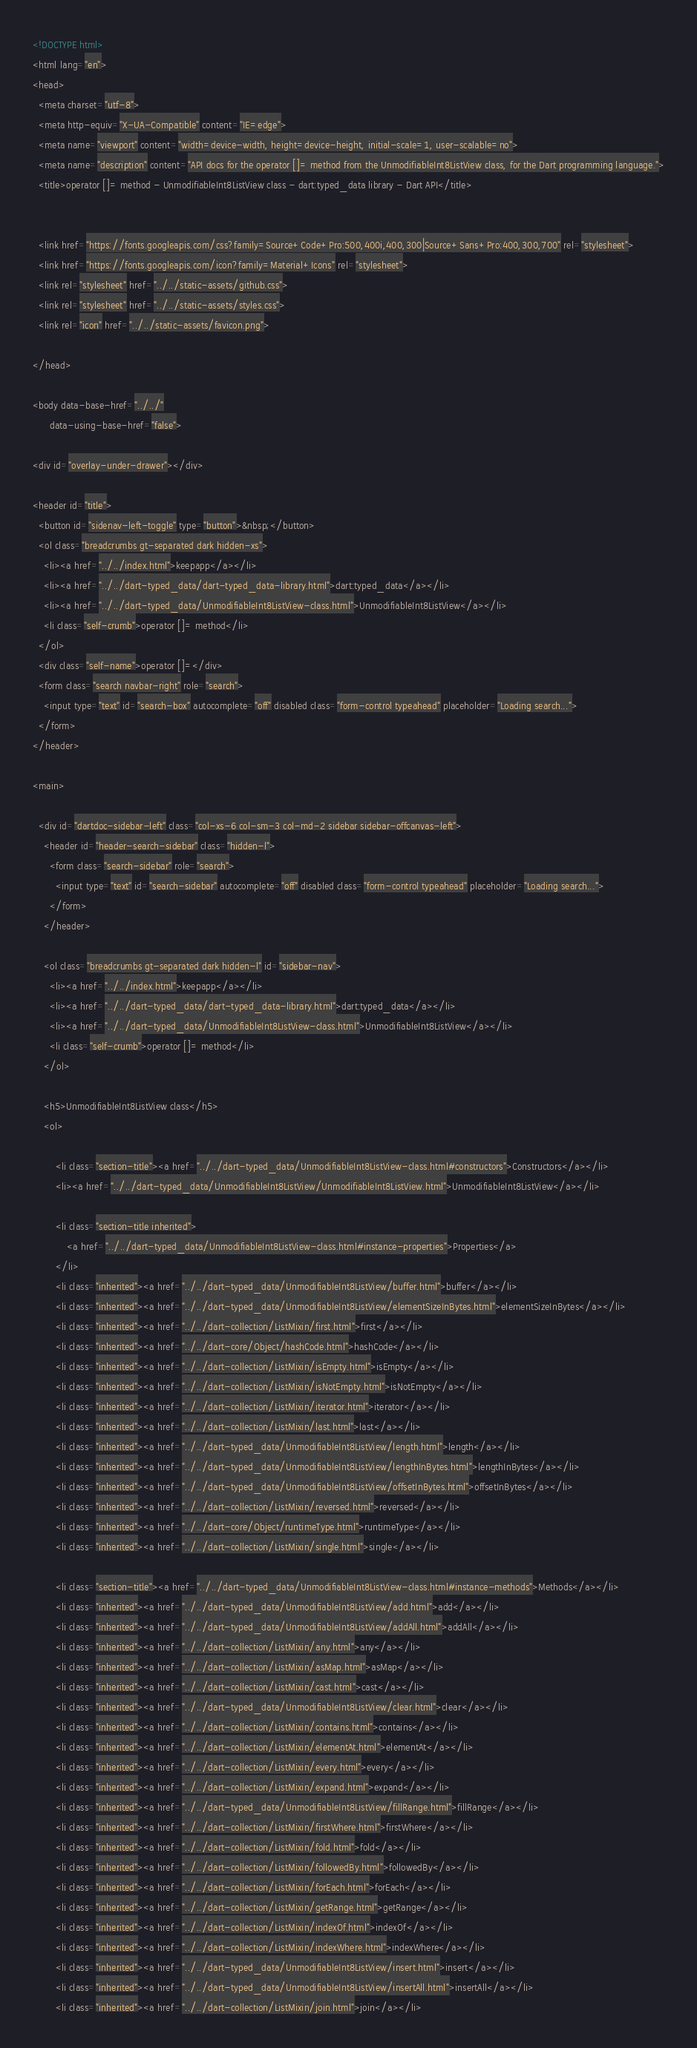Convert code to text. <code><loc_0><loc_0><loc_500><loc_500><_HTML_><!DOCTYPE html>
<html lang="en">
<head>
  <meta charset="utf-8">
  <meta http-equiv="X-UA-Compatible" content="IE=edge">
  <meta name="viewport" content="width=device-width, height=device-height, initial-scale=1, user-scalable=no">
  <meta name="description" content="API docs for the operator []= method from the UnmodifiableInt8ListView class, for the Dart programming language.">
  <title>operator []= method - UnmodifiableInt8ListView class - dart:typed_data library - Dart API</title>

  
  <link href="https://fonts.googleapis.com/css?family=Source+Code+Pro:500,400i,400,300|Source+Sans+Pro:400,300,700" rel="stylesheet">
  <link href="https://fonts.googleapis.com/icon?family=Material+Icons" rel="stylesheet">
  <link rel="stylesheet" href="../../static-assets/github.css">
  <link rel="stylesheet" href="../../static-assets/styles.css">
  <link rel="icon" href="../../static-assets/favicon.png">

</head>

<body data-base-href="../../"
      data-using-base-href="false">

<div id="overlay-under-drawer"></div>

<header id="title">
  <button id="sidenav-left-toggle" type="button">&nbsp;</button>
  <ol class="breadcrumbs gt-separated dark hidden-xs">
    <li><a href="../../index.html">keepapp</a></li>
    <li><a href="../../dart-typed_data/dart-typed_data-library.html">dart:typed_data</a></li>
    <li><a href="../../dart-typed_data/UnmodifiableInt8ListView-class.html">UnmodifiableInt8ListView</a></li>
    <li class="self-crumb">operator []= method</li>
  </ol>
  <div class="self-name">operator []=</div>
  <form class="search navbar-right" role="search">
    <input type="text" id="search-box" autocomplete="off" disabled class="form-control typeahead" placeholder="Loading search...">
  </form>
</header>

<main>

  <div id="dartdoc-sidebar-left" class="col-xs-6 col-sm-3 col-md-2 sidebar sidebar-offcanvas-left">
    <header id="header-search-sidebar" class="hidden-l">
      <form class="search-sidebar" role="search">
        <input type="text" id="search-sidebar" autocomplete="off" disabled class="form-control typeahead" placeholder="Loading search...">
      </form>
    </header>
    
    <ol class="breadcrumbs gt-separated dark hidden-l" id="sidebar-nav">
      <li><a href="../../index.html">keepapp</a></li>
      <li><a href="../../dart-typed_data/dart-typed_data-library.html">dart:typed_data</a></li>
      <li><a href="../../dart-typed_data/UnmodifiableInt8ListView-class.html">UnmodifiableInt8ListView</a></li>
      <li class="self-crumb">operator []= method</li>
    </ol>
    
    <h5>UnmodifiableInt8ListView class</h5>
    <ol>
    
        <li class="section-title"><a href="../../dart-typed_data/UnmodifiableInt8ListView-class.html#constructors">Constructors</a></li>
        <li><a href="../../dart-typed_data/UnmodifiableInt8ListView/UnmodifiableInt8ListView.html">UnmodifiableInt8ListView</a></li>
    
        <li class="section-title inherited">
            <a href="../../dart-typed_data/UnmodifiableInt8ListView-class.html#instance-properties">Properties</a>
        </li>
        <li class="inherited"><a href="../../dart-typed_data/UnmodifiableInt8ListView/buffer.html">buffer</a></li>
        <li class="inherited"><a href="../../dart-typed_data/UnmodifiableInt8ListView/elementSizeInBytes.html">elementSizeInBytes</a></li>
        <li class="inherited"><a href="../../dart-collection/ListMixin/first.html">first</a></li>
        <li class="inherited"><a href="../../dart-core/Object/hashCode.html">hashCode</a></li>
        <li class="inherited"><a href="../../dart-collection/ListMixin/isEmpty.html">isEmpty</a></li>
        <li class="inherited"><a href="../../dart-collection/ListMixin/isNotEmpty.html">isNotEmpty</a></li>
        <li class="inherited"><a href="../../dart-collection/ListMixin/iterator.html">iterator</a></li>
        <li class="inherited"><a href="../../dart-collection/ListMixin/last.html">last</a></li>
        <li class="inherited"><a href="../../dart-typed_data/UnmodifiableInt8ListView/length.html">length</a></li>
        <li class="inherited"><a href="../../dart-typed_data/UnmodifiableInt8ListView/lengthInBytes.html">lengthInBytes</a></li>
        <li class="inherited"><a href="../../dart-typed_data/UnmodifiableInt8ListView/offsetInBytes.html">offsetInBytes</a></li>
        <li class="inherited"><a href="../../dart-collection/ListMixin/reversed.html">reversed</a></li>
        <li class="inherited"><a href="../../dart-core/Object/runtimeType.html">runtimeType</a></li>
        <li class="inherited"><a href="../../dart-collection/ListMixin/single.html">single</a></li>
    
        <li class="section-title"><a href="../../dart-typed_data/UnmodifiableInt8ListView-class.html#instance-methods">Methods</a></li>
        <li class="inherited"><a href="../../dart-typed_data/UnmodifiableInt8ListView/add.html">add</a></li>
        <li class="inherited"><a href="../../dart-typed_data/UnmodifiableInt8ListView/addAll.html">addAll</a></li>
        <li class="inherited"><a href="../../dart-collection/ListMixin/any.html">any</a></li>
        <li class="inherited"><a href="../../dart-collection/ListMixin/asMap.html">asMap</a></li>
        <li class="inherited"><a href="../../dart-collection/ListMixin/cast.html">cast</a></li>
        <li class="inherited"><a href="../../dart-typed_data/UnmodifiableInt8ListView/clear.html">clear</a></li>
        <li class="inherited"><a href="../../dart-collection/ListMixin/contains.html">contains</a></li>
        <li class="inherited"><a href="../../dart-collection/ListMixin/elementAt.html">elementAt</a></li>
        <li class="inherited"><a href="../../dart-collection/ListMixin/every.html">every</a></li>
        <li class="inherited"><a href="../../dart-collection/ListMixin/expand.html">expand</a></li>
        <li class="inherited"><a href="../../dart-typed_data/UnmodifiableInt8ListView/fillRange.html">fillRange</a></li>
        <li class="inherited"><a href="../../dart-collection/ListMixin/firstWhere.html">firstWhere</a></li>
        <li class="inherited"><a href="../../dart-collection/ListMixin/fold.html">fold</a></li>
        <li class="inherited"><a href="../../dart-collection/ListMixin/followedBy.html">followedBy</a></li>
        <li class="inherited"><a href="../../dart-collection/ListMixin/forEach.html">forEach</a></li>
        <li class="inherited"><a href="../../dart-collection/ListMixin/getRange.html">getRange</a></li>
        <li class="inherited"><a href="../../dart-collection/ListMixin/indexOf.html">indexOf</a></li>
        <li class="inherited"><a href="../../dart-collection/ListMixin/indexWhere.html">indexWhere</a></li>
        <li class="inherited"><a href="../../dart-typed_data/UnmodifiableInt8ListView/insert.html">insert</a></li>
        <li class="inherited"><a href="../../dart-typed_data/UnmodifiableInt8ListView/insertAll.html">insertAll</a></li>
        <li class="inherited"><a href="../../dart-collection/ListMixin/join.html">join</a></li></code> 